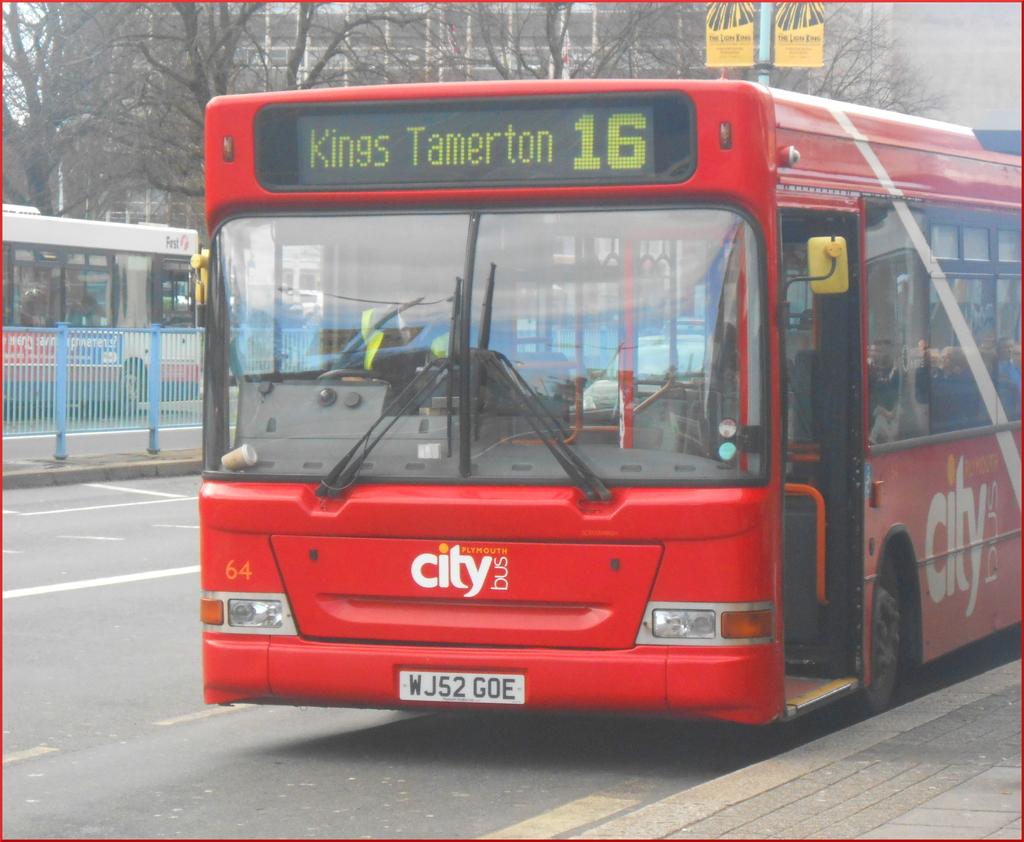Where is the bus route?
Provide a succinct answer. Kings tamerton. What is the plate number?
Your answer should be compact. Wj52 goe. 